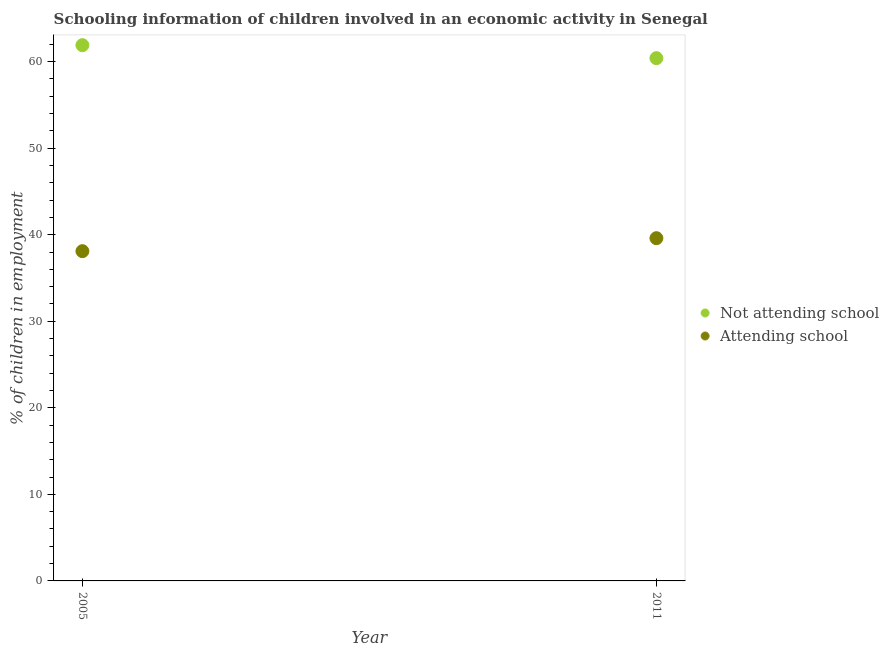What is the percentage of employed children who are not attending school in 2011?
Give a very brief answer. 60.4. Across all years, what is the maximum percentage of employed children who are not attending school?
Provide a succinct answer. 61.9. Across all years, what is the minimum percentage of employed children who are not attending school?
Provide a short and direct response. 60.4. In which year was the percentage of employed children who are attending school maximum?
Offer a very short reply. 2011. In which year was the percentage of employed children who are not attending school minimum?
Offer a terse response. 2011. What is the total percentage of employed children who are attending school in the graph?
Keep it short and to the point. 77.7. What is the difference between the percentage of employed children who are attending school in 2011 and the percentage of employed children who are not attending school in 2005?
Your response must be concise. -22.3. What is the average percentage of employed children who are attending school per year?
Make the answer very short. 38.85. In the year 2011, what is the difference between the percentage of employed children who are attending school and percentage of employed children who are not attending school?
Keep it short and to the point. -20.8. What is the ratio of the percentage of employed children who are attending school in 2005 to that in 2011?
Keep it short and to the point. 0.96. Is the percentage of employed children who are not attending school in 2005 less than that in 2011?
Offer a very short reply. No. In how many years, is the percentage of employed children who are not attending school greater than the average percentage of employed children who are not attending school taken over all years?
Ensure brevity in your answer.  1. Does the percentage of employed children who are not attending school monotonically increase over the years?
Keep it short and to the point. No. How many years are there in the graph?
Make the answer very short. 2. Are the values on the major ticks of Y-axis written in scientific E-notation?
Give a very brief answer. No. Does the graph contain any zero values?
Your answer should be compact. No. Does the graph contain grids?
Offer a terse response. No. Where does the legend appear in the graph?
Your response must be concise. Center right. How are the legend labels stacked?
Give a very brief answer. Vertical. What is the title of the graph?
Ensure brevity in your answer.  Schooling information of children involved in an economic activity in Senegal. What is the label or title of the X-axis?
Provide a succinct answer. Year. What is the label or title of the Y-axis?
Give a very brief answer. % of children in employment. What is the % of children in employment in Not attending school in 2005?
Offer a terse response. 61.9. What is the % of children in employment in Attending school in 2005?
Your answer should be compact. 38.1. What is the % of children in employment of Not attending school in 2011?
Give a very brief answer. 60.4. What is the % of children in employment in Attending school in 2011?
Make the answer very short. 39.6. Across all years, what is the maximum % of children in employment of Not attending school?
Offer a terse response. 61.9. Across all years, what is the maximum % of children in employment of Attending school?
Provide a succinct answer. 39.6. Across all years, what is the minimum % of children in employment in Not attending school?
Offer a terse response. 60.4. Across all years, what is the minimum % of children in employment in Attending school?
Keep it short and to the point. 38.1. What is the total % of children in employment in Not attending school in the graph?
Offer a very short reply. 122.3. What is the total % of children in employment in Attending school in the graph?
Your answer should be very brief. 77.7. What is the difference between the % of children in employment in Not attending school in 2005 and that in 2011?
Your answer should be very brief. 1.5. What is the difference between the % of children in employment of Not attending school in 2005 and the % of children in employment of Attending school in 2011?
Provide a short and direct response. 22.3. What is the average % of children in employment of Not attending school per year?
Keep it short and to the point. 61.15. What is the average % of children in employment in Attending school per year?
Offer a terse response. 38.85. In the year 2005, what is the difference between the % of children in employment of Not attending school and % of children in employment of Attending school?
Your response must be concise. 23.8. In the year 2011, what is the difference between the % of children in employment of Not attending school and % of children in employment of Attending school?
Ensure brevity in your answer.  20.8. What is the ratio of the % of children in employment in Not attending school in 2005 to that in 2011?
Provide a succinct answer. 1.02. What is the ratio of the % of children in employment in Attending school in 2005 to that in 2011?
Ensure brevity in your answer.  0.96. What is the difference between the highest and the second highest % of children in employment of Attending school?
Provide a short and direct response. 1.5. What is the difference between the highest and the lowest % of children in employment of Not attending school?
Give a very brief answer. 1.5. What is the difference between the highest and the lowest % of children in employment of Attending school?
Your answer should be very brief. 1.5. 